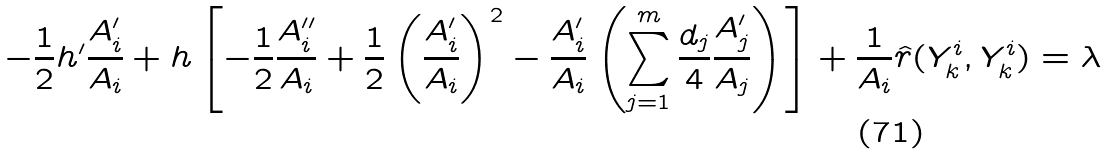<formula> <loc_0><loc_0><loc_500><loc_500>- \frac { 1 } { 2 } h ^ { \prime } \frac { A _ { i } ^ { \prime } } { A _ { i } } + h \left [ - \frac { 1 } { 2 } \frac { A _ { i } ^ { \prime \prime } } { A _ { i } } + \frac { 1 } { 2 } \left ( \frac { A _ { i } ^ { \prime } } { A _ { i } } \right ) ^ { 2 } - \frac { A _ { i } ^ { \prime } } { A _ { i } } \left ( \sum _ { j = 1 } ^ { m } \frac { d _ { j } } { 4 } \frac { A _ { j } ^ { \prime } } { A _ { j } } \right ) \right ] + \frac { 1 } { A _ { i } } \hat { r } ( Y _ { k } ^ { i } , Y ^ { i } _ { k } ) = \lambda</formula> 